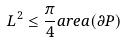<formula> <loc_0><loc_0><loc_500><loc_500>L ^ { 2 } \leq \frac { \pi } { 4 } a r e a ( \partial P )</formula> 